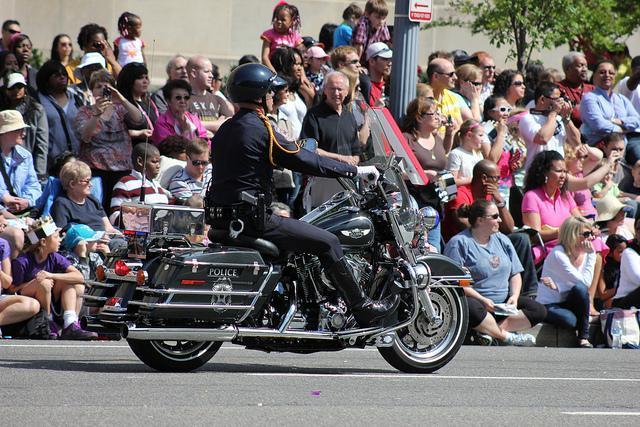How many police officers are in this scene?
Give a very brief answer. 1. How many people can you see?
Give a very brief answer. 11. How many airplanes are parked here?
Give a very brief answer. 0. 